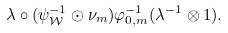<formula> <loc_0><loc_0><loc_500><loc_500>\lambda \circ ( \psi _ { \mathcal { W } } ^ { - 1 } \odot \nu _ { m } ) \varphi _ { 0 , m } ^ { - 1 } ( \lambda ^ { - 1 } \otimes 1 ) .</formula> 